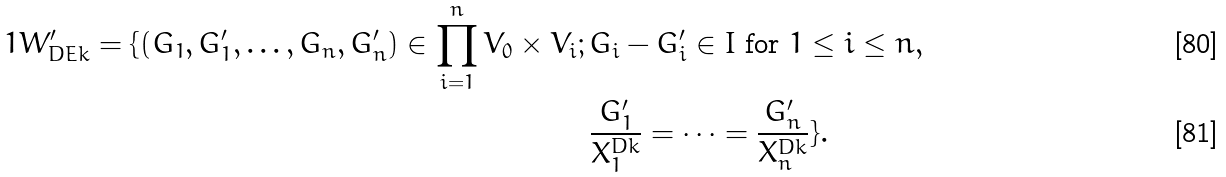Convert formula to latex. <formula><loc_0><loc_0><loc_500><loc_500>1 W ^ { \prime } _ { D E k } = \{ ( G _ { 1 } , G ^ { \prime } _ { 1 } , \dots , G _ { n } , G ^ { \prime } _ { n } ) \in \prod _ { i = 1 } ^ { n } V _ { 0 } \times V _ { i } ; \, & G _ { i } - G ^ { \prime } _ { i } \in I \text { for } 1 \leq i \leq n , \\ & \frac { G ^ { \prime } _ { 1 } } { X _ { 1 } ^ { D k } } = \cdots = \frac { G ^ { \prime } _ { n } } { X _ { n } ^ { D k } } \} .</formula> 